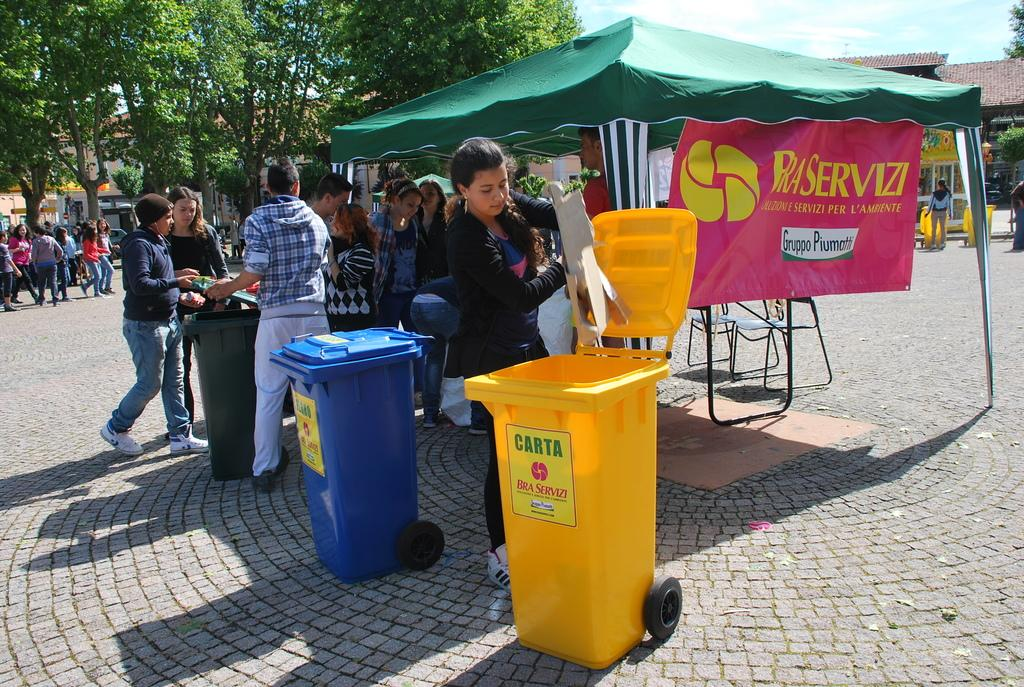<image>
Present a compact description of the photo's key features. A woman putting trash into a yellow container with a sign that says CARTA. 